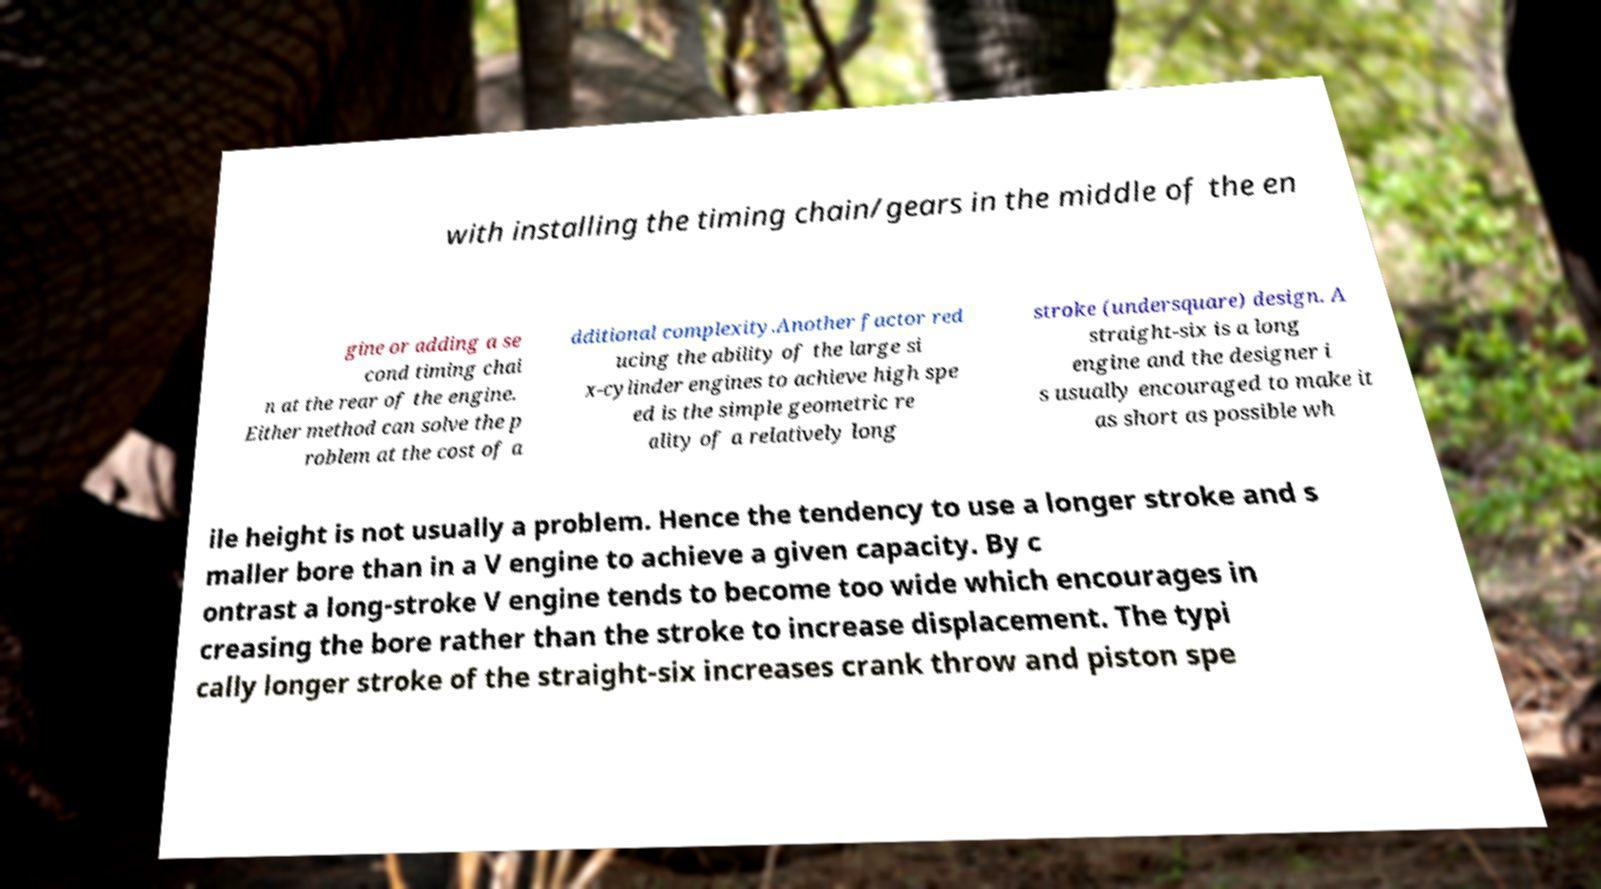For documentation purposes, I need the text within this image transcribed. Could you provide that? with installing the timing chain/gears in the middle of the en gine or adding a se cond timing chai n at the rear of the engine. Either method can solve the p roblem at the cost of a dditional complexity.Another factor red ucing the ability of the large si x-cylinder engines to achieve high spe ed is the simple geometric re ality of a relatively long stroke (undersquare) design. A straight-six is a long engine and the designer i s usually encouraged to make it as short as possible wh ile height is not usually a problem. Hence the tendency to use a longer stroke and s maller bore than in a V engine to achieve a given capacity. By c ontrast a long-stroke V engine tends to become too wide which encourages in creasing the bore rather than the stroke to increase displacement. The typi cally longer stroke of the straight-six increases crank throw and piston spe 